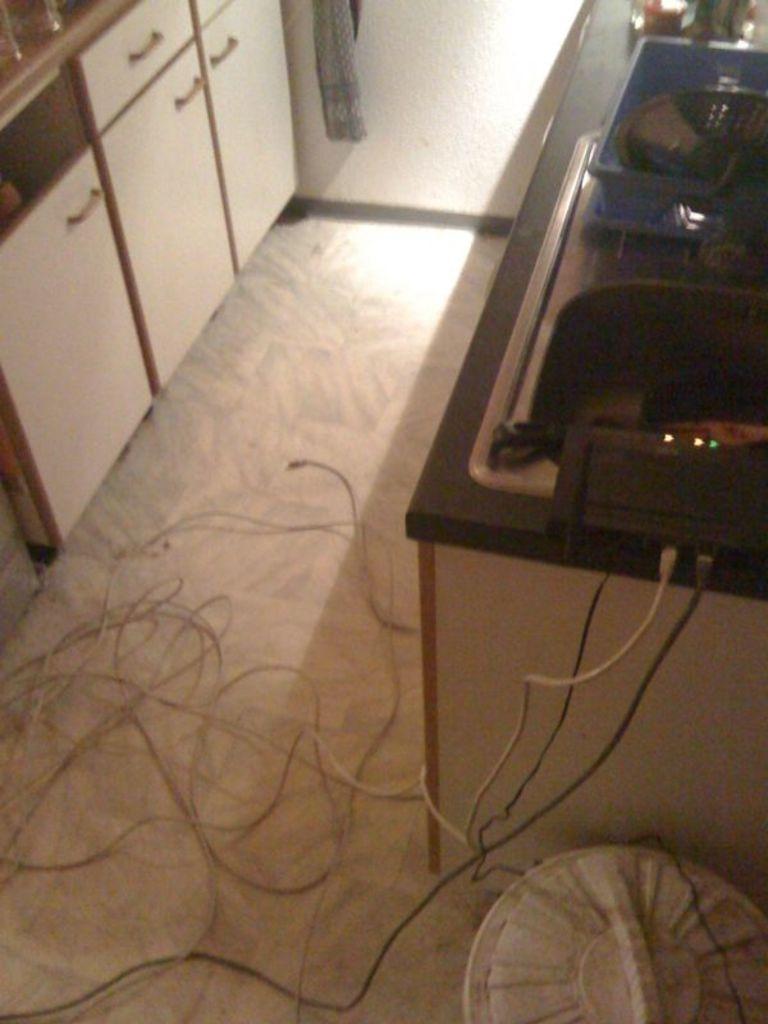Describe this image in one or two sentences. This is an inside view. At the bottom there are few wires on the floor. On the right side there is a table on which a basket, a device and some other objects are placed. Beside the table there is a bin. In the top left I can see the table cabinets. In the background there is a wall. 